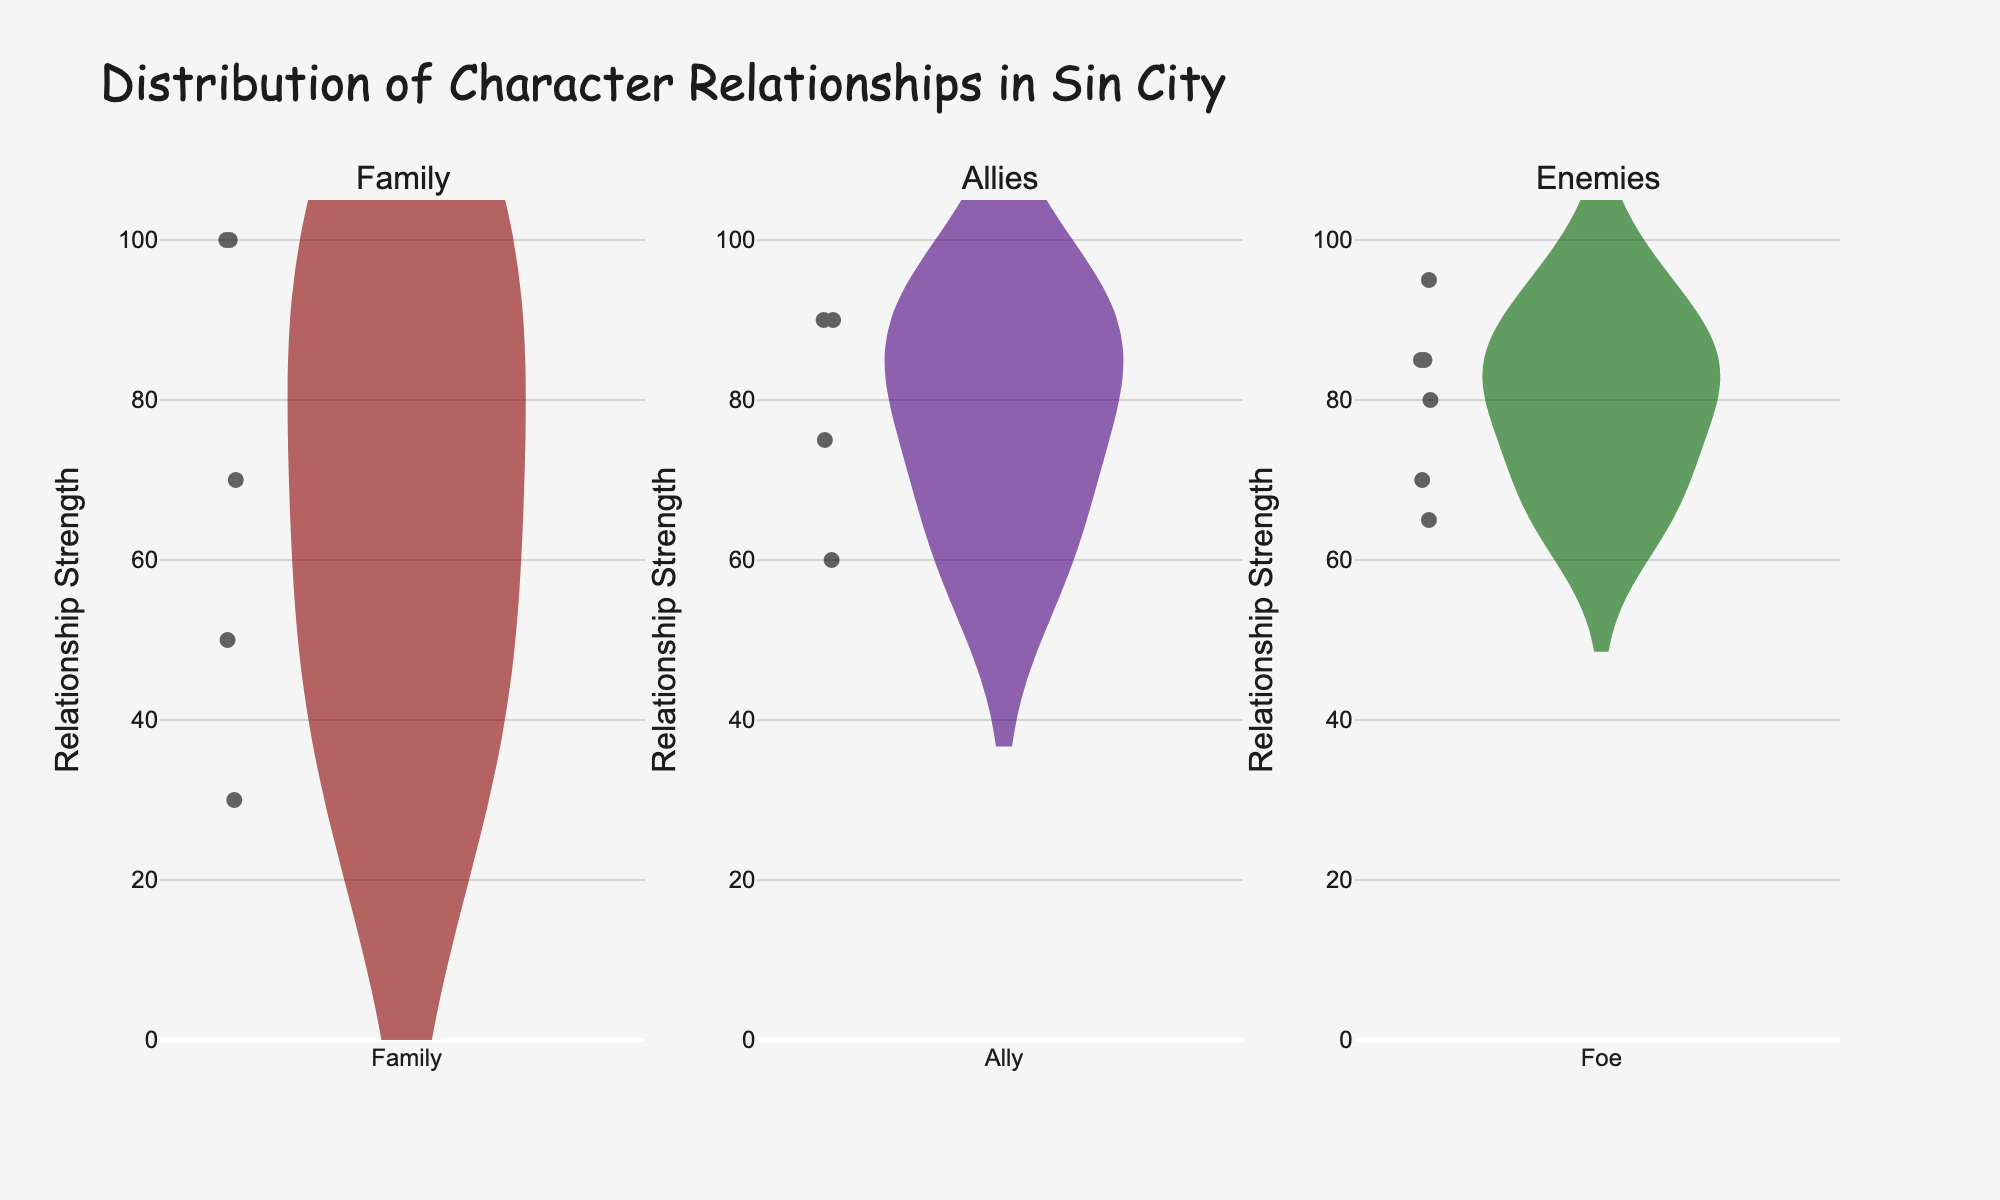What is the title of the figure? The title is typically displayed at the top of the figure. In this case, it reads "Distribution of Character Relationships in Sin City."
Answer: Distribution of Character Relationships in Sin City Which relationship type has the highest median strength? By inspecting the horizontal line inside the violin plots (representing the median), we can compare the median values of each relationship type. The Family violin plot has the highest median.
Answer: Family How does the distribution of Enemy relationship strengths compare to Allies? By comparing the spread and density of the violin plots for Enemies and Allies, we can observe that the distribution of Enemy relationship strengths is broader with a concentration of values between 70 and 85, while Allies have a tighter spread around higher values.
Answer: Enemies have broader, Allies have tighter spread What is the range of relationship strengths for Family relationships? The range can be determined by observing the extents of the Family violin plot. The minimum strength value is around 30, and the maximum is 100.
Answer: 30 to 100 Which character has the highest single relationship strength, and what type is it? We identify the highest point in the figure. Hartigan and Nancy’s Family relationship has the highest strength at 100.
Answer: Hartigan and Nancy, Family How many unique relationship types are plotted in the figure? By looking at the subplot titles, which are Family, Allies, and Enemies, we count three unique relationship types.
Answer: Three What is the mean strength value for Ally relationships? The mean is represented by a line within the violin plot. Referring to the Allies subplot, we can estimate the mean value as being around 75.
Answer: Around 75 Which relationship type has the tightest interquartile range (middle 50% of data)? Interquartile range is visible as the width of the central box in the violin plots. By comparing, we see that Allies have the tightest interquartile range.
Answer: Allies How does the maximum strength for Foe relationships compare to Family? The maximum for Foe is around 95, while for Family it is 100. So, the Family's maximum is greater.
Answer: Family greater than Foe Which relationship type includes the widest spread of strengths? Looking at the widths of the violin plots from minimum to maximum values, the Family plot spans the largest range from 30 to 100.
Answer: Family 